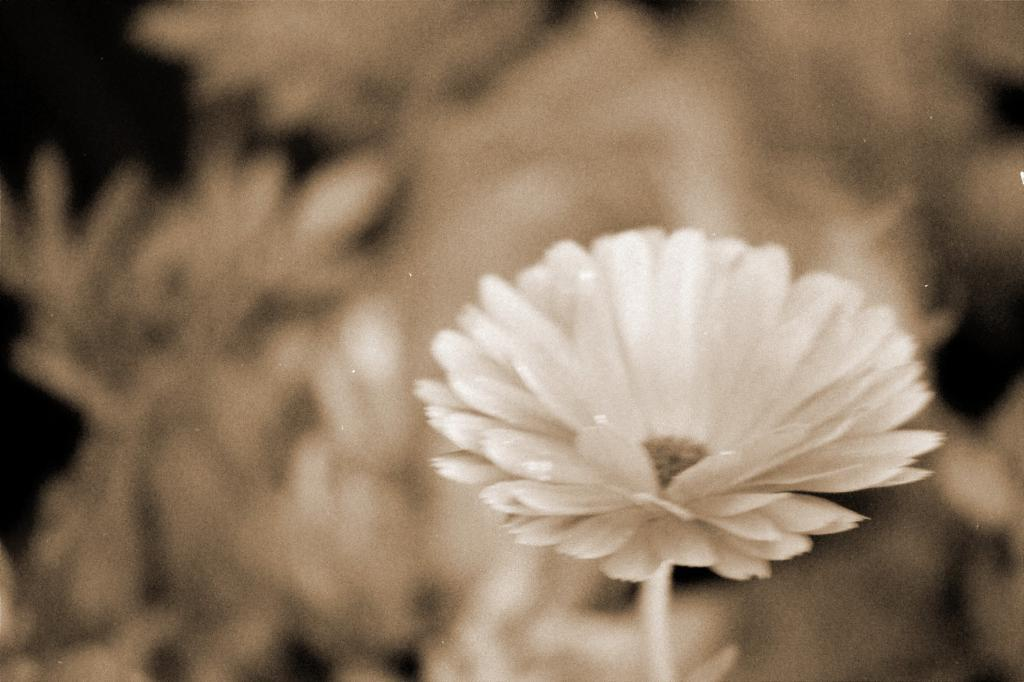What is the color scheme of the image? The image is black and white. What type of plant can be seen in the image? There is a flower in the image. What part of the flower is visible in the image? There is a stem associated with the flower. Can you describe the background of the image? The background of the image is blurred. What type of dirt can be seen on the sheet in the image? There is no sheet or dirt present in the image; it features a black and white flower with a blurred background. 